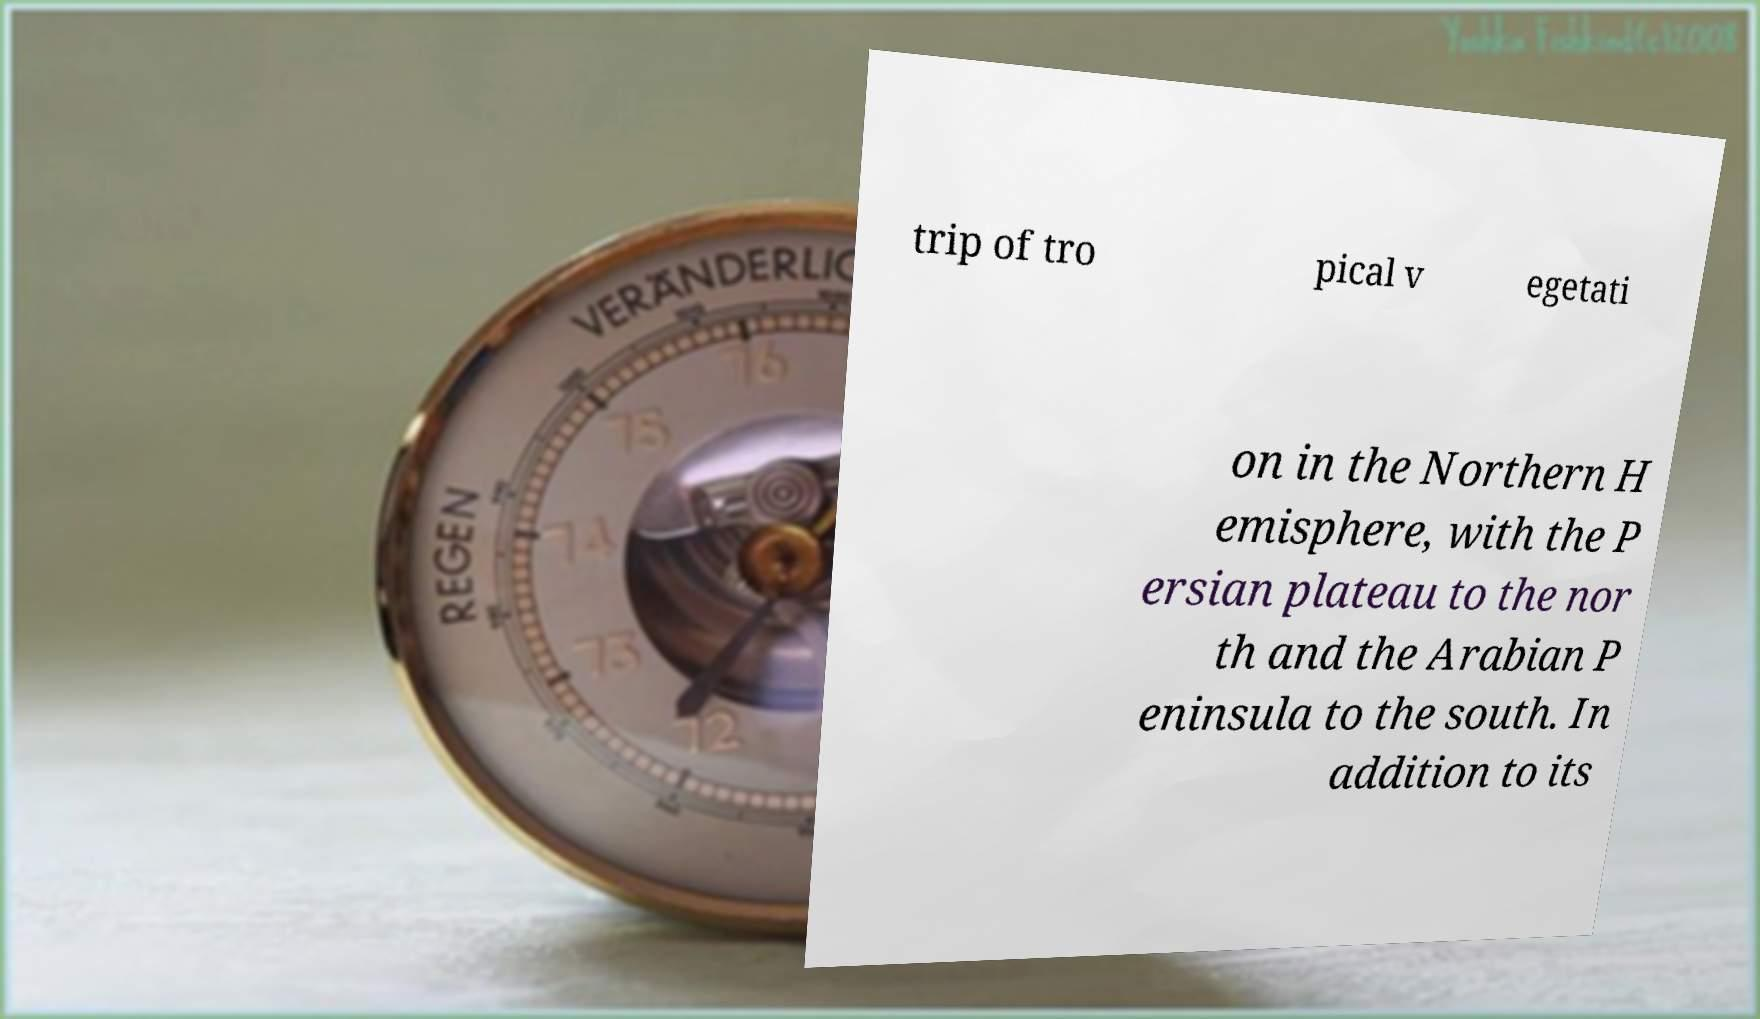Could you assist in decoding the text presented in this image and type it out clearly? trip of tro pical v egetati on in the Northern H emisphere, with the P ersian plateau to the nor th and the Arabian P eninsula to the south. In addition to its 